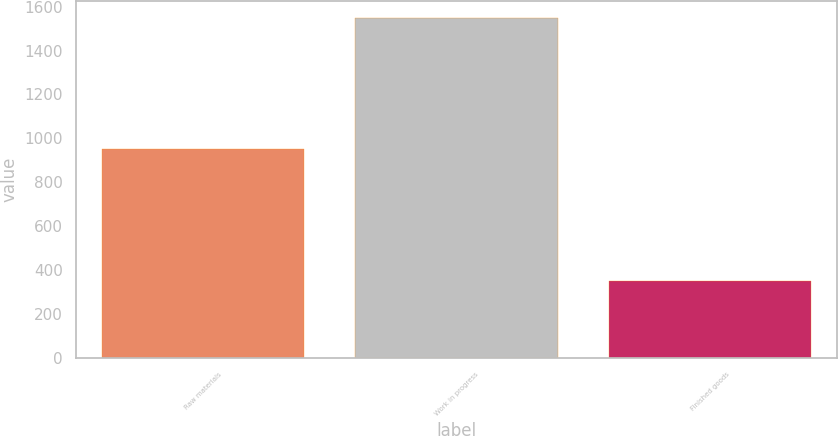Convert chart. <chart><loc_0><loc_0><loc_500><loc_500><bar_chart><fcel>Raw materials<fcel>Work in progress<fcel>Finished goods<nl><fcel>953<fcel>1547<fcel>352<nl></chart> 